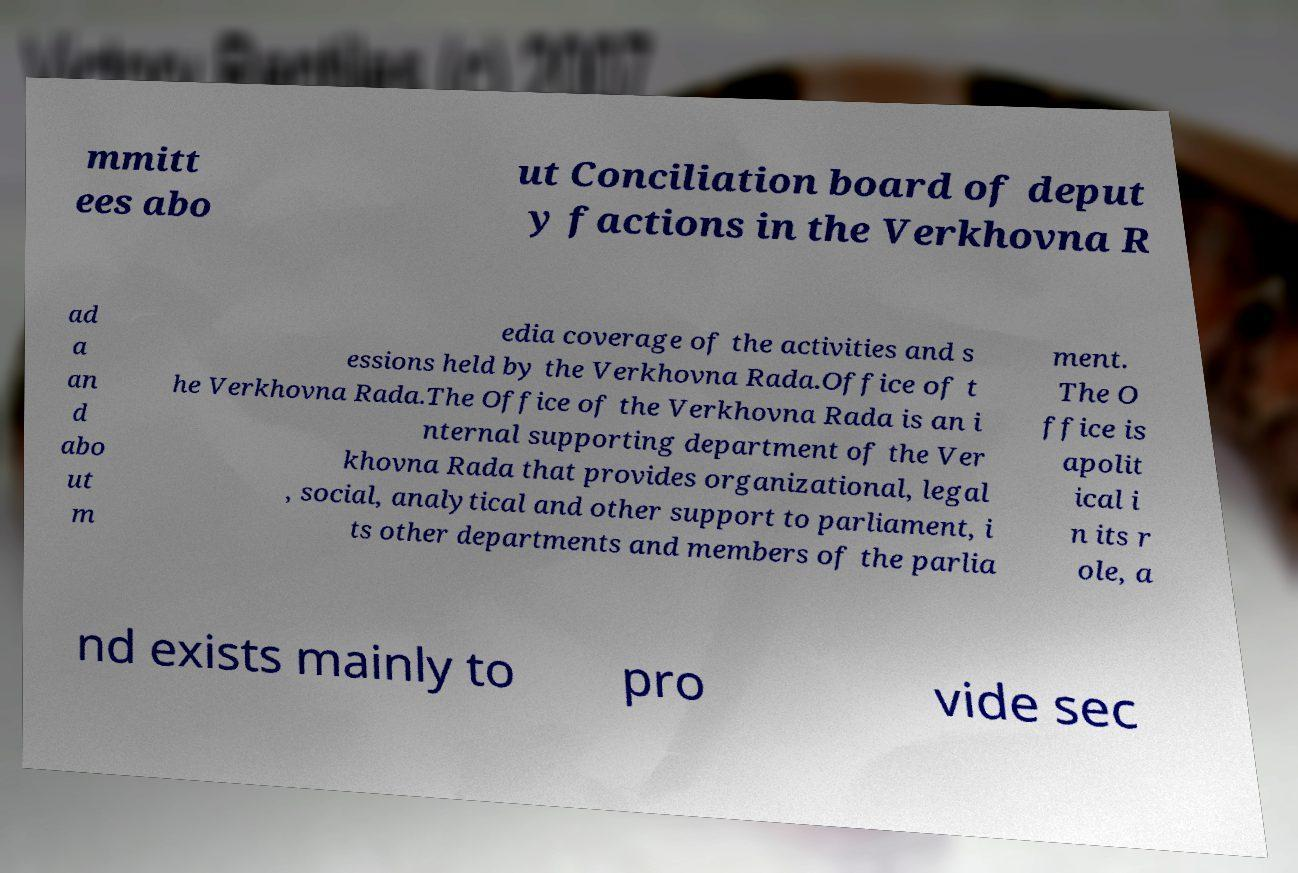Please read and relay the text visible in this image. What does it say? mmitt ees abo ut Conciliation board of deput y factions in the Verkhovna R ad a an d abo ut m edia coverage of the activities and s essions held by the Verkhovna Rada.Office of t he Verkhovna Rada.The Office of the Verkhovna Rada is an i nternal supporting department of the Ver khovna Rada that provides organizational, legal , social, analytical and other support to parliament, i ts other departments and members of the parlia ment. The O ffice is apolit ical i n its r ole, a nd exists mainly to pro vide sec 